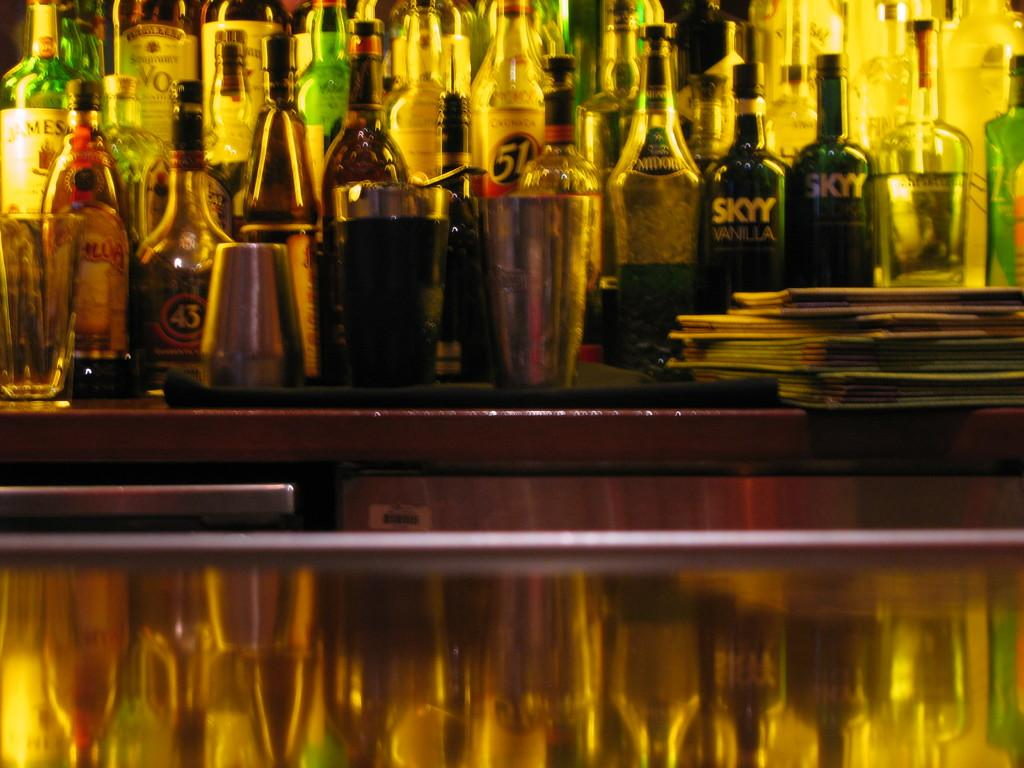<image>
Render a clear and concise summary of the photo. Two bottles of Skyy vodka is sitting on a shelf with several other bottles of liquor. 